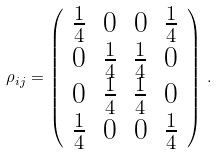<formula> <loc_0><loc_0><loc_500><loc_500>\rho _ { i j } = \left ( \begin{array} { c c c c } \frac { 1 } { 4 } & 0 & 0 & \frac { 1 } { 4 } \\ 0 & \frac { 1 } { 4 } & \frac { 1 } { 4 } & 0 \\ 0 & \frac { 1 } { 4 } & \frac { 1 } { 4 } & 0 \\ \frac { 1 } { 4 } & 0 & 0 & \frac { 1 } { 4 } \end{array} \right ) \, .</formula> 